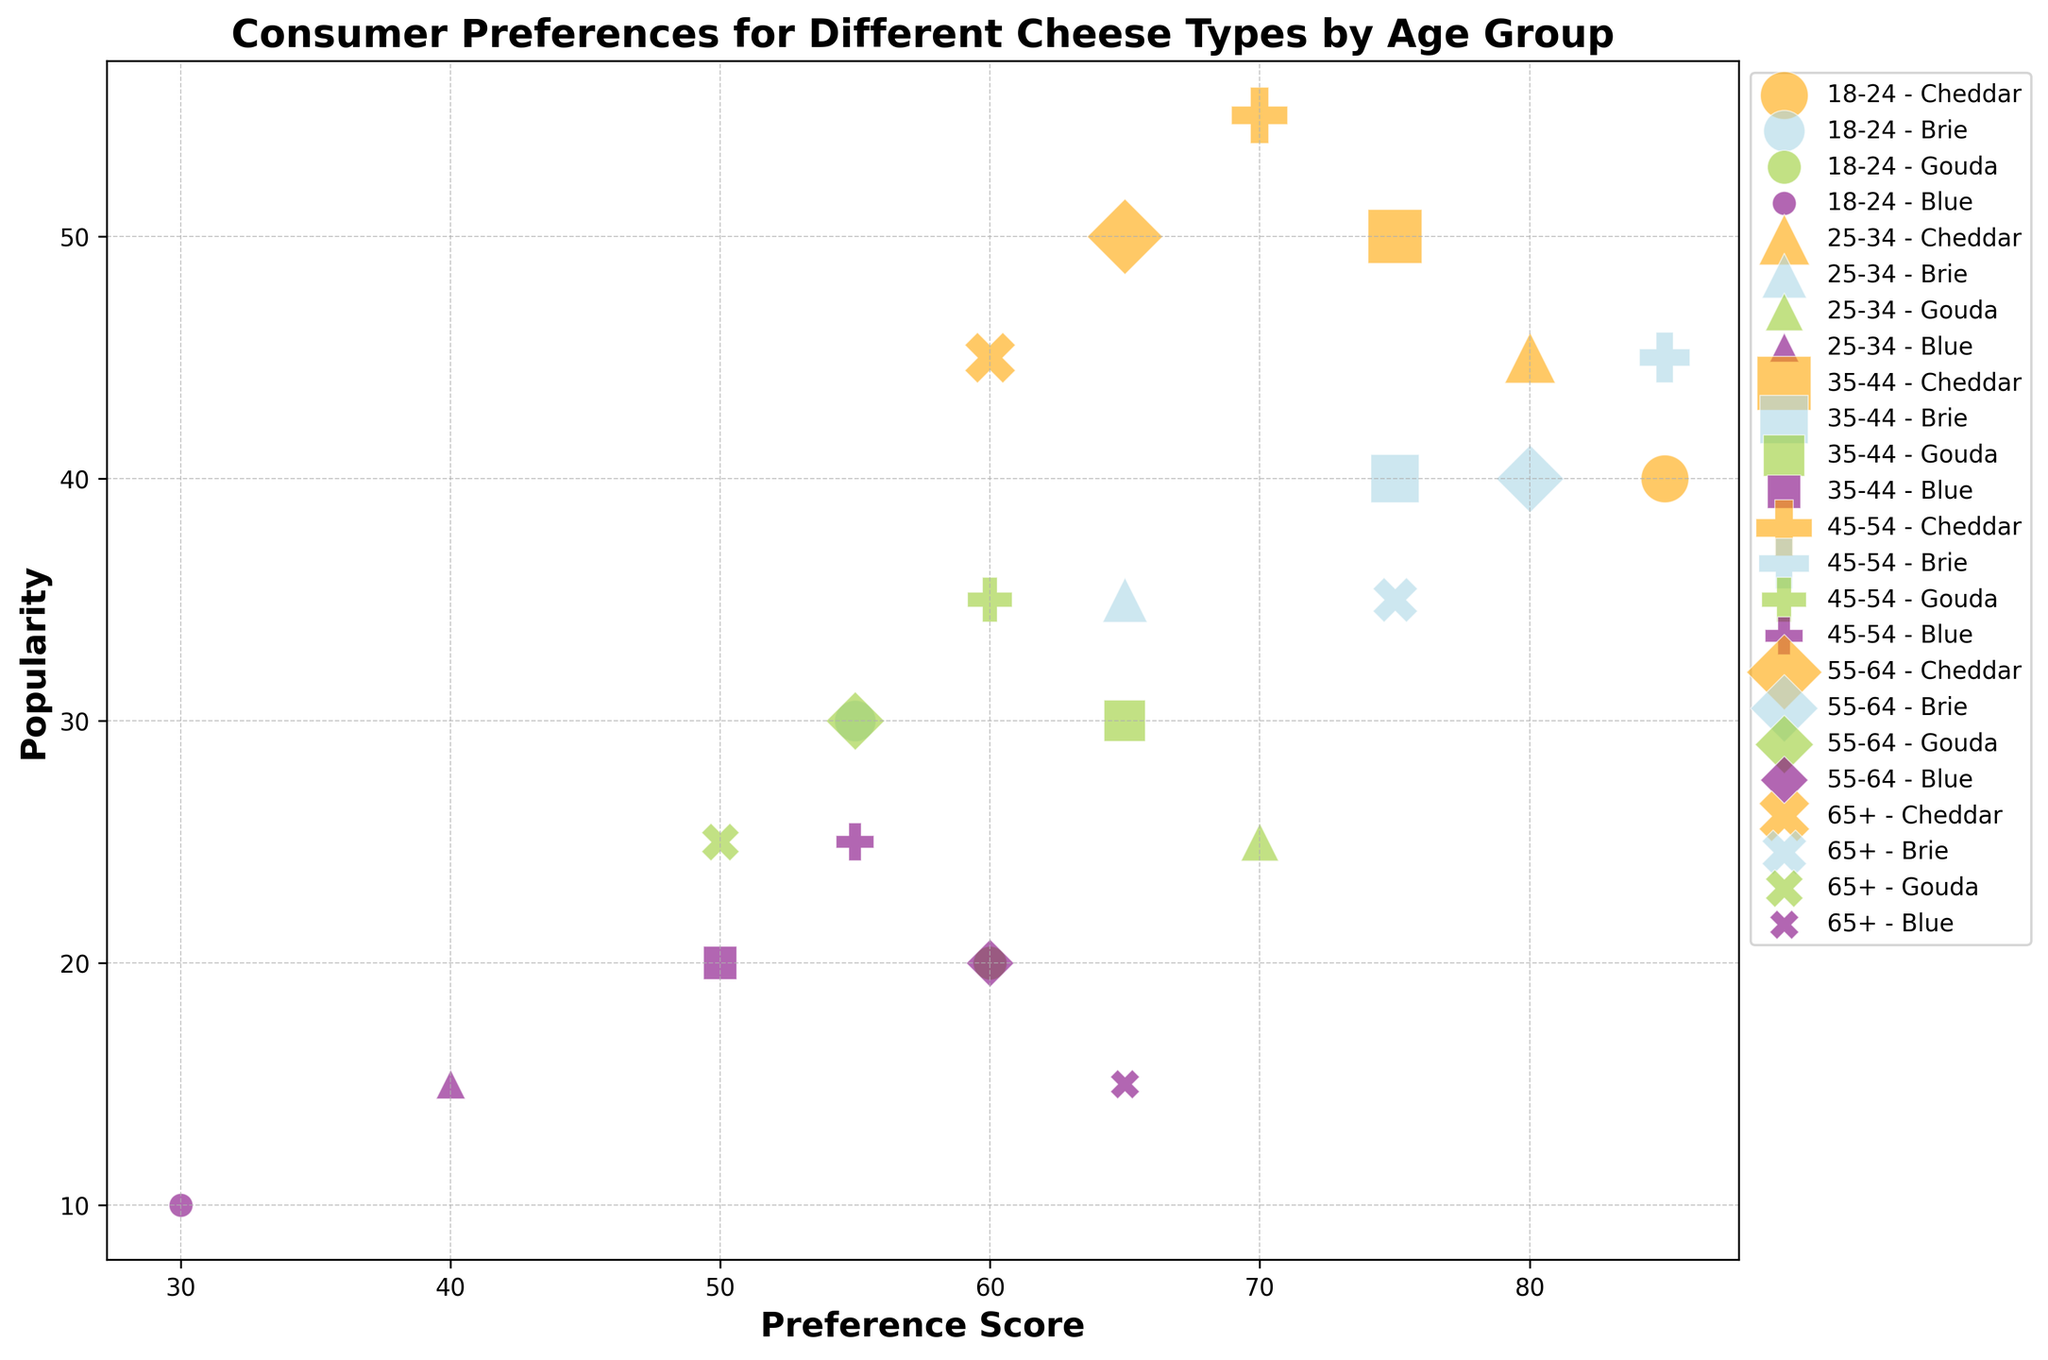How does the preference score for Cheddar change across the different age groups? First, identify Cheddar preference scores for each age group from the figure. Then, observe the trend: 85 (18-24), 80 (25-34), 75 (35-44), 70 (45-54), 65 (55-64), and 60 (65+). Notice that the preference score decreases as the age group increases.
Answer: Decreases Which age group has the highest popularity for Brie? Look at the bubble sizes for Brie in each age group. Identify the age group with the largest bubble. The popularity values for Brie are 30 (18-24), 35 (25-34), 40 (35-44), 45 (45-54), 40 (55-64), and 35 (65+). The largest bubble corresponds to the 45-54 age group.
Answer: 45-54 Among the age groups 25-34 and 35-44, which one has the higher preference score for Blue cheese? Compare the Blue cheese preference scores directly for the 25-34 (40) and 35-44 (50) age groups as shown in the figure. The score of 50 is higher than 40.
Answer: 35-44 What's the average popularity of Gouda cheese across all age groups? Identify the popularity values for Gouda in each age group: 20 (18-24), 25 (25-34), 30 (35-44), 35 (45-54), 30 (55-64), and 25 (65+). Sum them up: 20 + 25 + 30 + 35 + 30 + 25 = 165. There are 6 age groups. The average is 165 / 6 = 27.5.
Answer: 27.5 Does the 55-64 age group have a higher preference score for Blue cheese compared to the 65+ age group? Compare the preference scores for Blue cheese in the 55-64 (60) and 65+ (65) age groups. 65 is greater than 60.
Answer: No Which cheese type is the most popular among the 35-44 age group? Examine the bubble sizes for all cheese types within the 35-44 age group and identify the largest bubble. The popularity values are Cheddar (50), Brie (40), Gouda (30), and Blue (20). Cheddar has the largest bubble.
Answer: Cheddar Calculate the preference score difference for Brie between the 18-24 and 45-54 age groups. Extract the preference scores for Brie in the 18-24 (55) and 45-54 (85) age groups. Subtract 55 from 85: 85 - 55 = 30.
Answer: 30 Which age group shows the highest preference score for Blue cheese? Identify the preference scores for Blue cheese in all age groups: 10 (18-24), 15 (25-34), 20 (35-44), 25 (45-54), 20 (55-64), 15 (65+). The highest score is in the 45-54 age group.
Answer: 45-54 